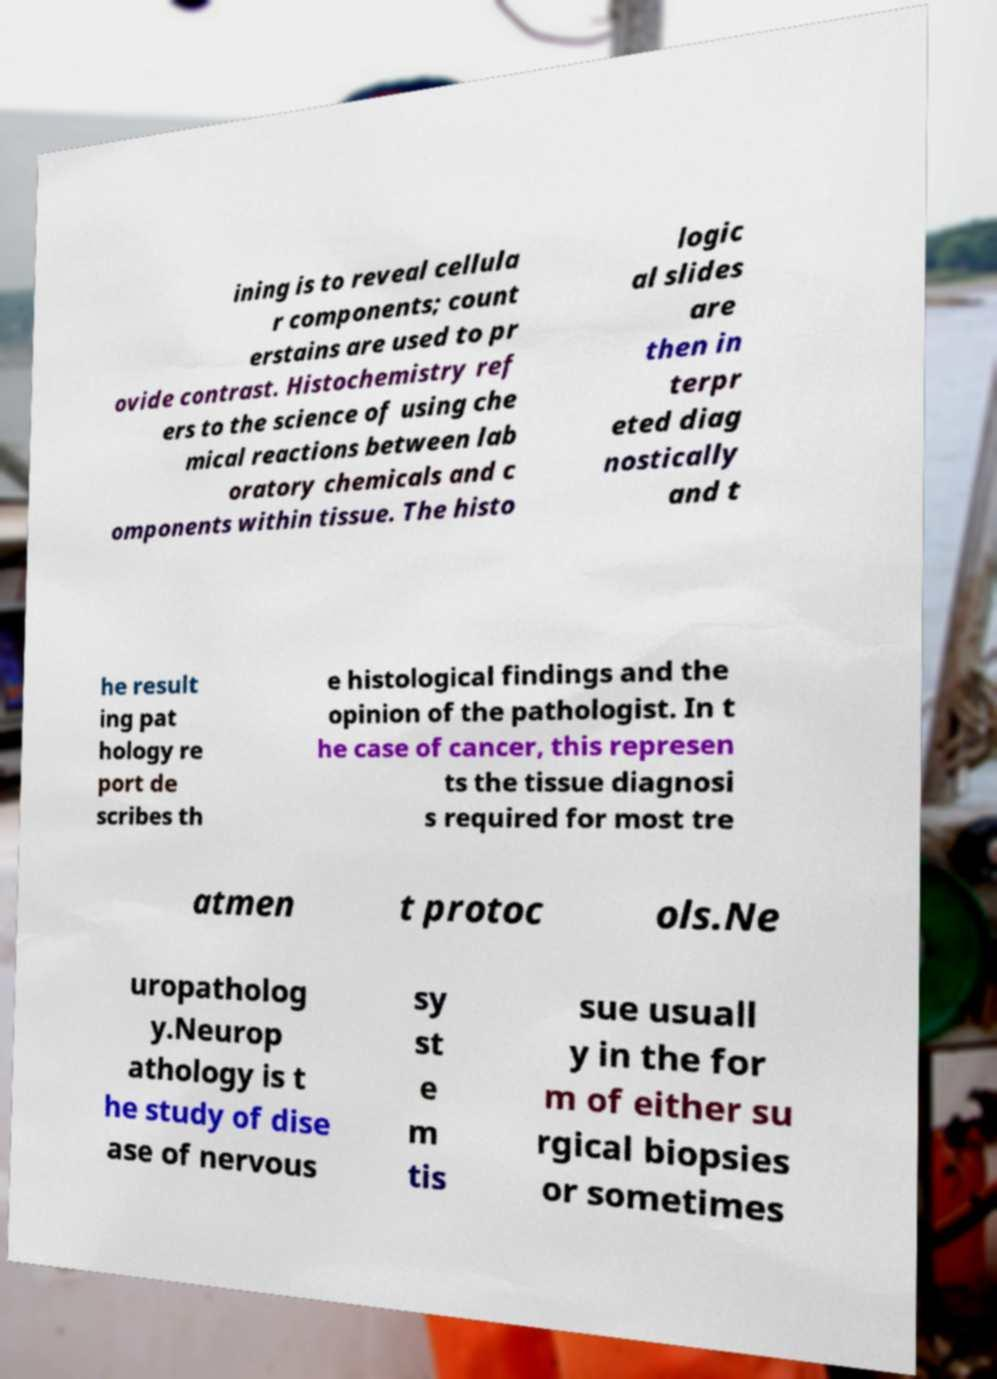Could you extract and type out the text from this image? ining is to reveal cellula r components; count erstains are used to pr ovide contrast. Histochemistry ref ers to the science of using che mical reactions between lab oratory chemicals and c omponents within tissue. The histo logic al slides are then in terpr eted diag nostically and t he result ing pat hology re port de scribes th e histological findings and the opinion of the pathologist. In t he case of cancer, this represen ts the tissue diagnosi s required for most tre atmen t protoc ols.Ne uropatholog y.Neurop athology is t he study of dise ase of nervous sy st e m tis sue usuall y in the for m of either su rgical biopsies or sometimes 